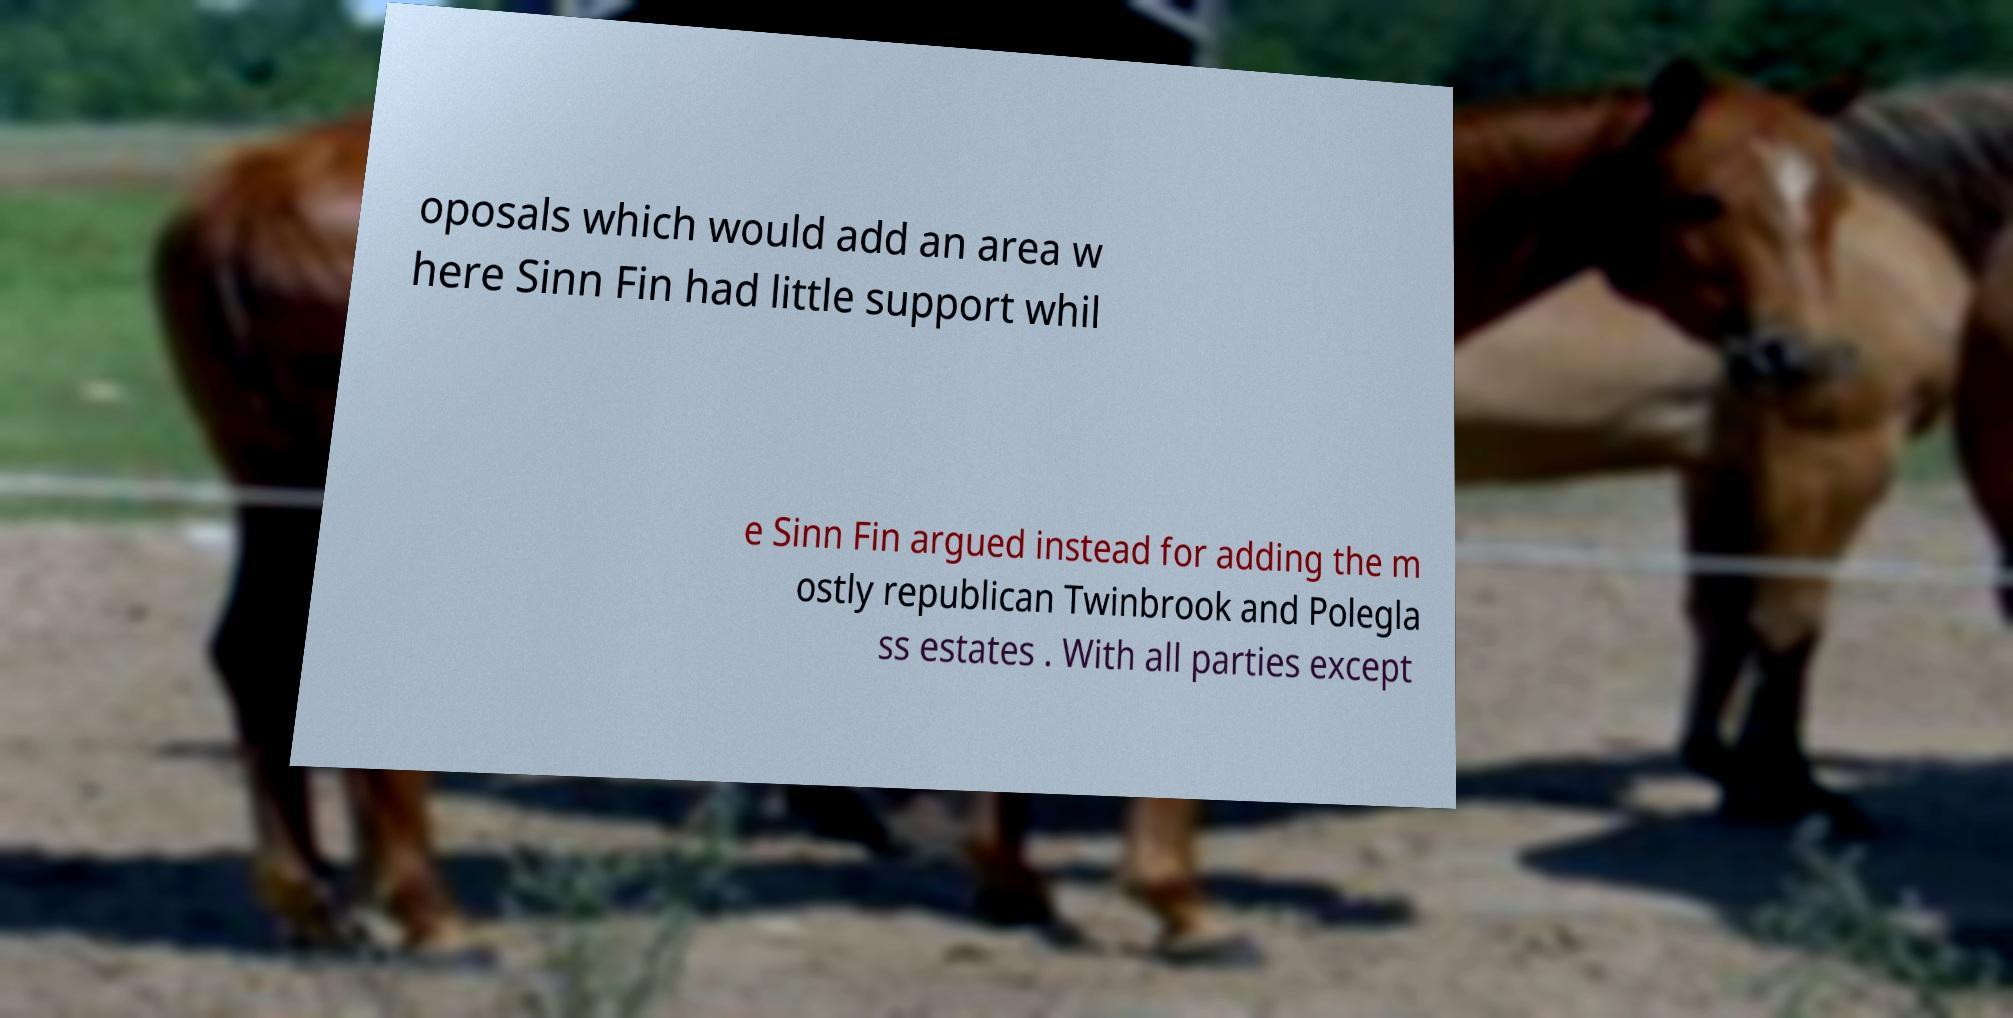Could you extract and type out the text from this image? oposals which would add an area w here Sinn Fin had little support whil e Sinn Fin argued instead for adding the m ostly republican Twinbrook and Polegla ss estates . With all parties except 